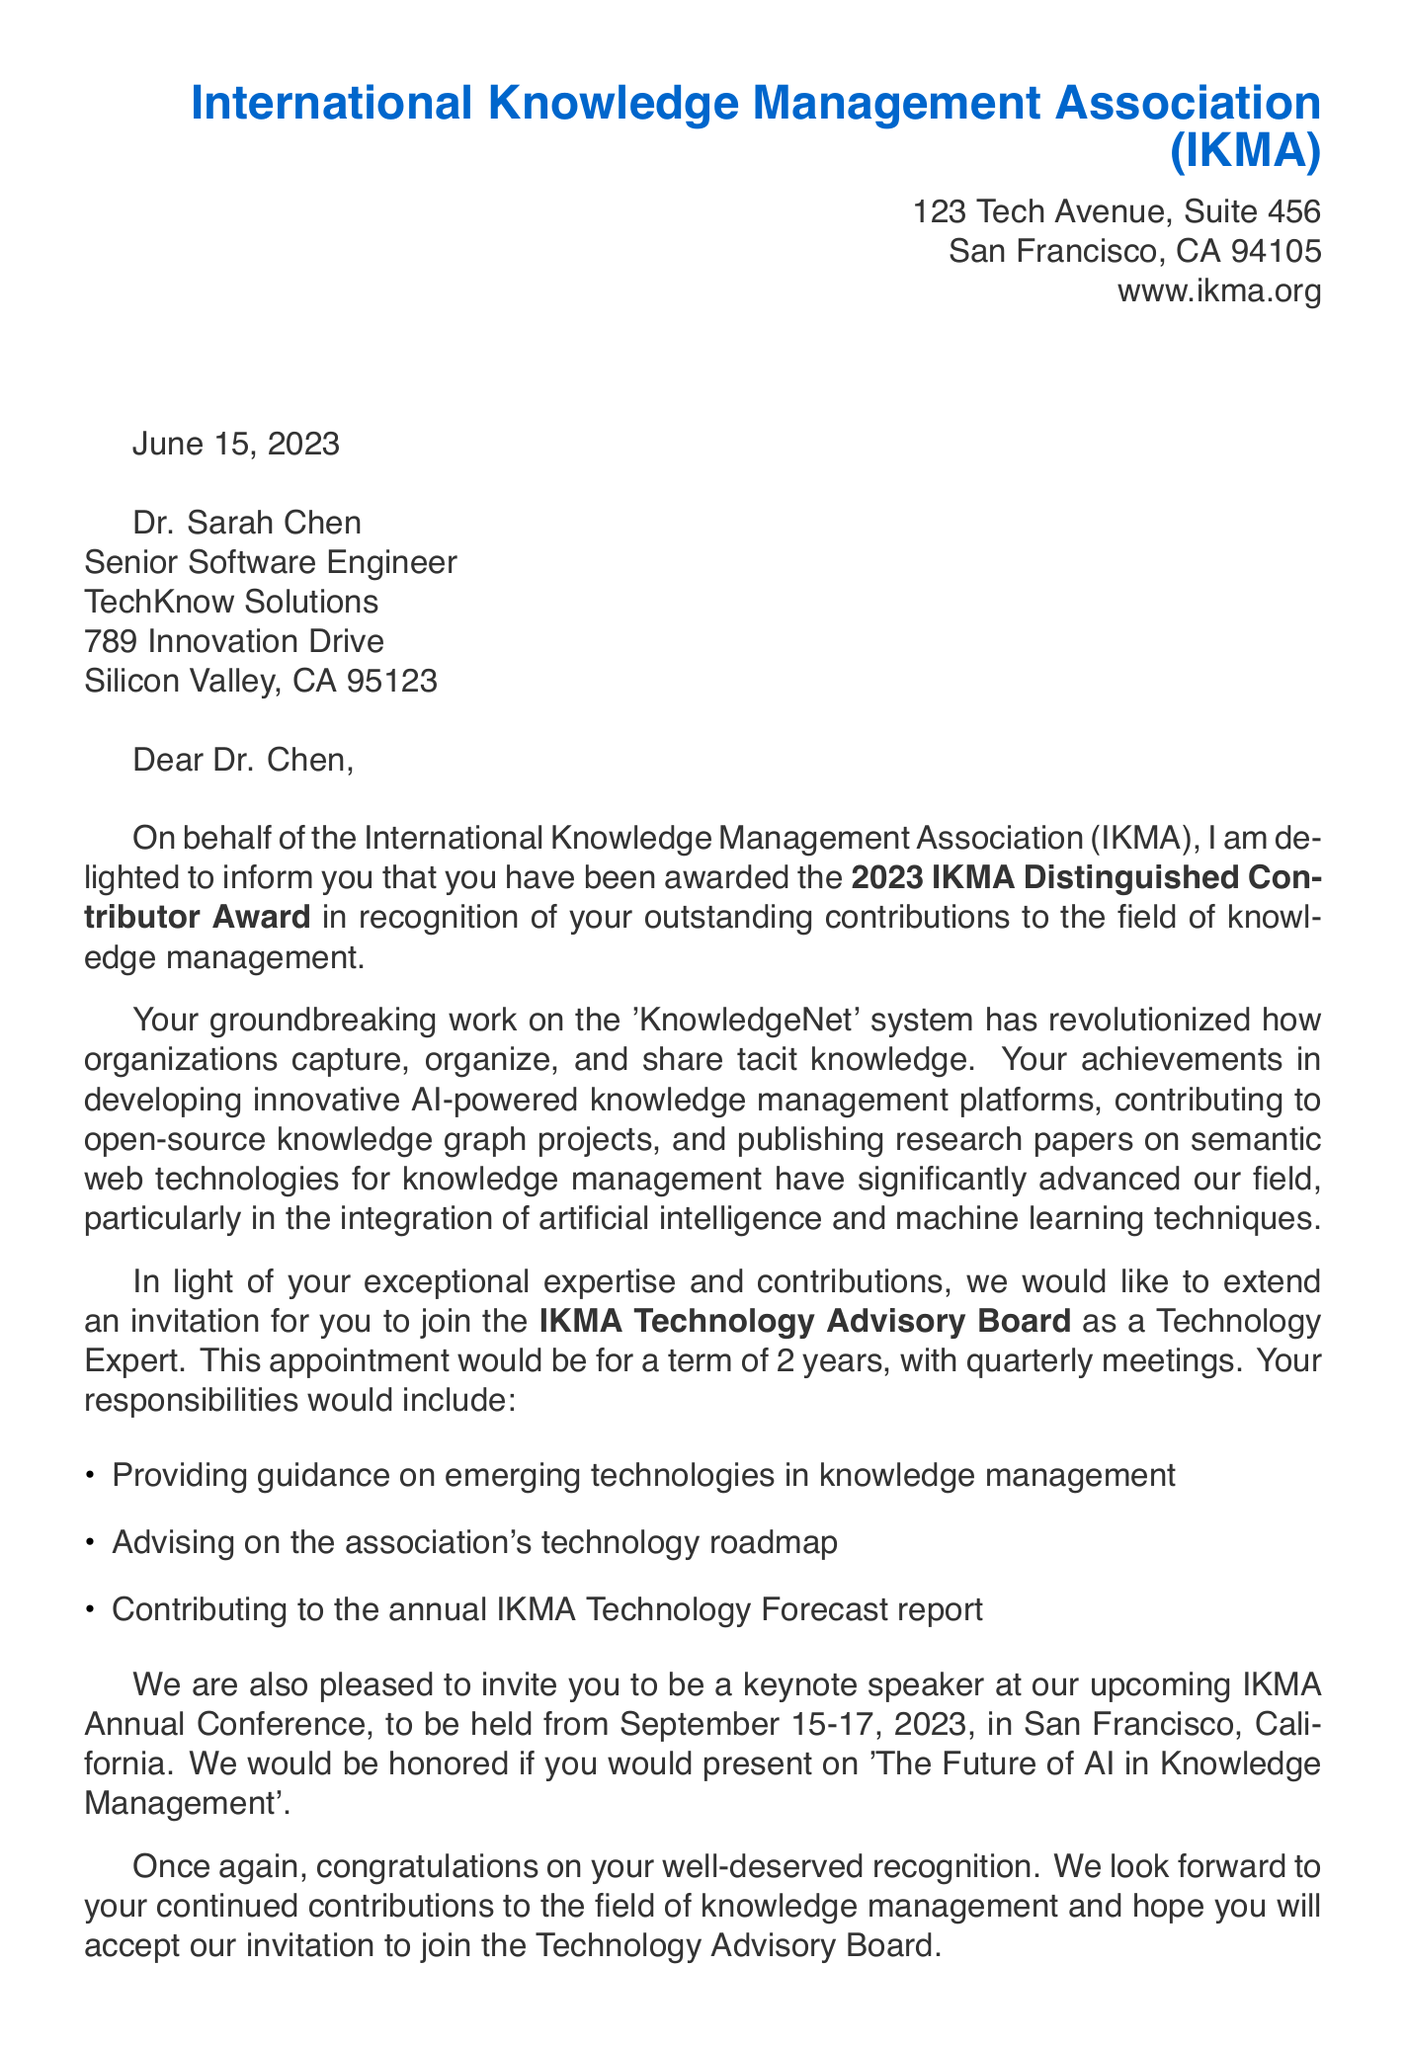What is the name of the association? The association's name is mentioned in the header of the letter, which is the International Knowledge Management Association (IKMA).
Answer: International Knowledge Management Association (IKMA) Who is the recipient of the letter? The letter is addressed to Dr. Sarah Chen, who is identified as the recipient.
Answer: Dr. Sarah Chen What award did Dr. Sarah Chen receive? The specific award given to Dr. Sarah Chen is stated to be the IKMA Distinguished Contributor Award in the letter.
Answer: IKMA Distinguished Contributor Award What is the duration of the term for the advisory board position? The term length for the IKMA Technology Advisory Board position is explicitly noted in the document.
Answer: 2 years What is one of Dr. Sarah Chen's responsibilities on the advisory board? The letter lists specific responsibilities, one of which includes providing guidance on emerging technologies in knowledge management.
Answer: Providing guidance on emerging technologies in knowledge management What event is Dr. Sarah Chen invited to speak at? The document mentions an upcoming event where Dr. Sarah Chen is invited to be a keynote speaker at the IKMA Annual Conference.
Answer: IKMA Annual Conference Who is the president of the association? The letter includes the name and title of the president of the association, which is Dr. Michael Thompson.
Answer: Dr. Michael Thompson What is the location of the upcoming conference? The document specifies the location of the IKMA Annual Conference, which is San Francisco, California.
Answer: San Francisco, California What is the contact person's email address? The document provides the email address of the contact person, Emily Rodriguez, Director of Member Relations.
Answer: emily.rodriguez@ikma.org What is the purpose of the letter? The letter serves to recognize Dr. Sarah Chen's contributions to the field of knowledge management and extend an invitation to join the advisory board.
Answer: Recognition and invitation to join the advisory board 